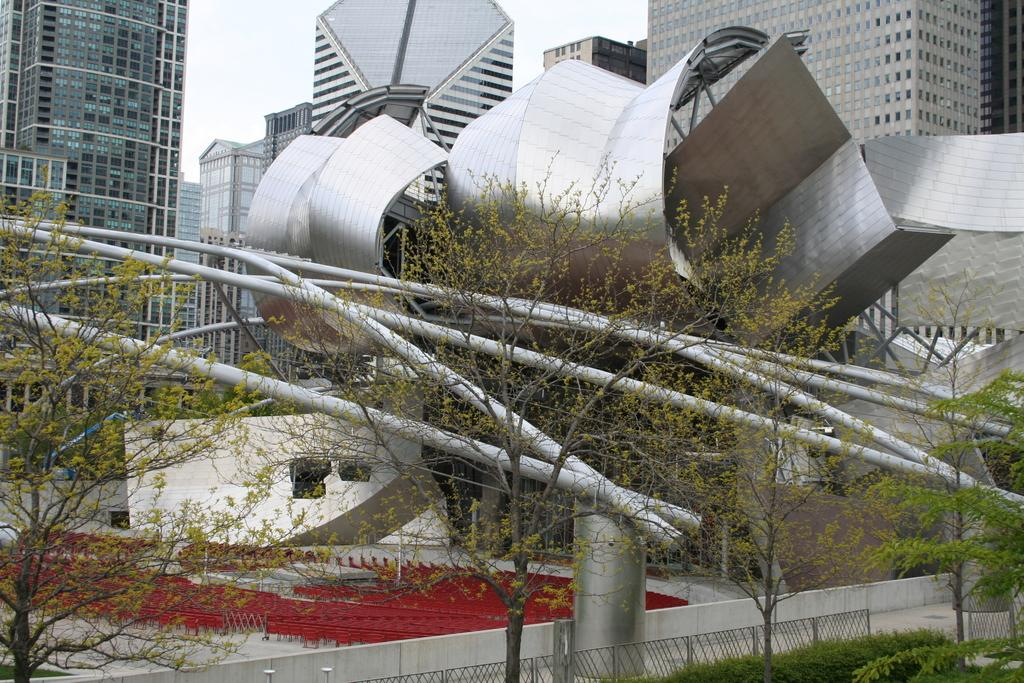What type of living organisms can be seen in the image? Plants can be seen in the image. What color are the plants in the image? The plants are green. What can be seen in the background of the image? There are buildings in the background of the image. What colors are the buildings in the image? The buildings are gray and cream in color. What type of buildings can be seen in the image? There are glass buildings in the image. What is the color of the sky in the image? The sky is white in color. What type of game is being played in the image? There is no game being played in the image; it features plants, buildings, and a white sky. How quiet is the environment in the image? The image does not provide any information about the noise level or quietness of the environment. 